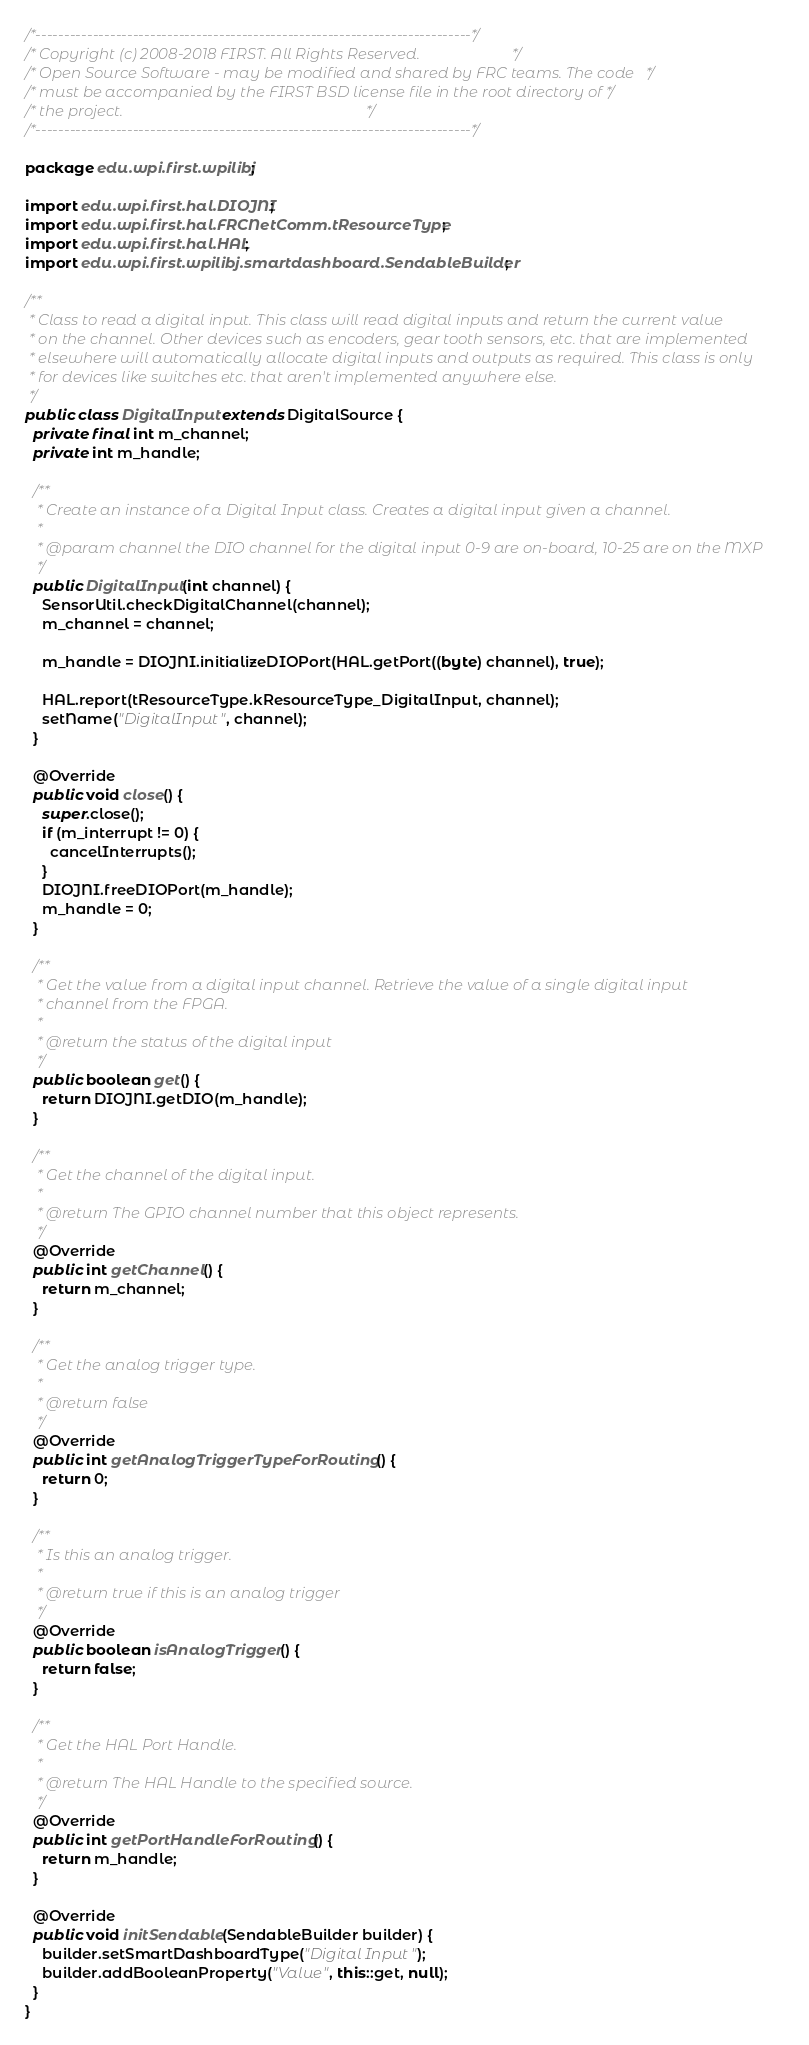Convert code to text. <code><loc_0><loc_0><loc_500><loc_500><_Java_>/*----------------------------------------------------------------------------*/
/* Copyright (c) 2008-2018 FIRST. All Rights Reserved.                        */
/* Open Source Software - may be modified and shared by FRC teams. The code   */
/* must be accompanied by the FIRST BSD license file in the root directory of */
/* the project.                                                               */
/*----------------------------------------------------------------------------*/

package edu.wpi.first.wpilibj;

import edu.wpi.first.hal.DIOJNI;
import edu.wpi.first.hal.FRCNetComm.tResourceType;
import edu.wpi.first.hal.HAL;
import edu.wpi.first.wpilibj.smartdashboard.SendableBuilder;

/**
 * Class to read a digital input. This class will read digital inputs and return the current value
 * on the channel. Other devices such as encoders, gear tooth sensors, etc. that are implemented
 * elsewhere will automatically allocate digital inputs and outputs as required. This class is only
 * for devices like switches etc. that aren't implemented anywhere else.
 */
public class DigitalInput extends DigitalSource {
  private final int m_channel;
  private int m_handle;

  /**
   * Create an instance of a Digital Input class. Creates a digital input given a channel.
   *
   * @param channel the DIO channel for the digital input 0-9 are on-board, 10-25 are on the MXP
   */
  public DigitalInput(int channel) {
    SensorUtil.checkDigitalChannel(channel);
    m_channel = channel;

    m_handle = DIOJNI.initializeDIOPort(HAL.getPort((byte) channel), true);

    HAL.report(tResourceType.kResourceType_DigitalInput, channel);
    setName("DigitalInput", channel);
  }

  @Override
  public void close() {
    super.close();
    if (m_interrupt != 0) {
      cancelInterrupts();
    }
    DIOJNI.freeDIOPort(m_handle);
    m_handle = 0;
  }

  /**
   * Get the value from a digital input channel. Retrieve the value of a single digital input
   * channel from the FPGA.
   *
   * @return the status of the digital input
   */
  public boolean get() {
    return DIOJNI.getDIO(m_handle);
  }

  /**
   * Get the channel of the digital input.
   *
   * @return The GPIO channel number that this object represents.
   */
  @Override
  public int getChannel() {
    return m_channel;
  }

  /**
   * Get the analog trigger type.
   *
   * @return false
   */
  @Override
  public int getAnalogTriggerTypeForRouting() {
    return 0;
  }

  /**
   * Is this an analog trigger.
   *
   * @return true if this is an analog trigger
   */
  @Override
  public boolean isAnalogTrigger() {
    return false;
  }

  /**
   * Get the HAL Port Handle.
   *
   * @return The HAL Handle to the specified source.
   */
  @Override
  public int getPortHandleForRouting() {
    return m_handle;
  }

  @Override
  public void initSendable(SendableBuilder builder) {
    builder.setSmartDashboardType("Digital Input");
    builder.addBooleanProperty("Value", this::get, null);
  }
}
</code> 